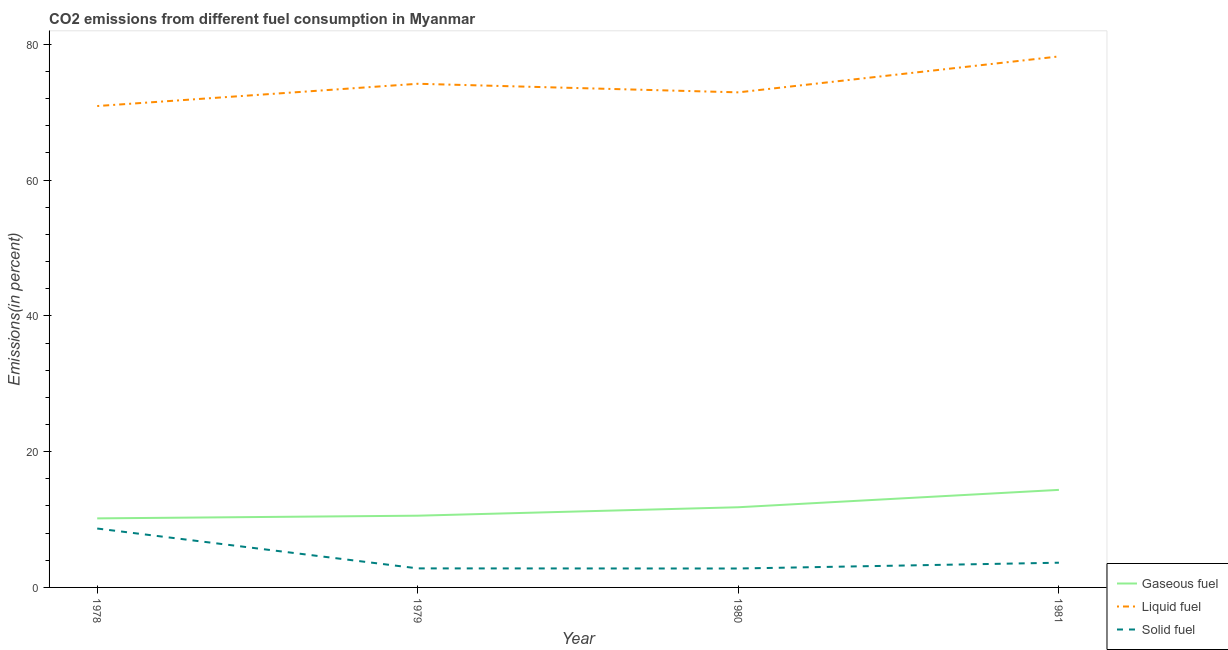How many different coloured lines are there?
Your answer should be compact. 3. Is the number of lines equal to the number of legend labels?
Ensure brevity in your answer.  Yes. What is the percentage of liquid fuel emission in 1978?
Your answer should be compact. 70.91. Across all years, what is the maximum percentage of gaseous fuel emission?
Ensure brevity in your answer.  14.37. Across all years, what is the minimum percentage of gaseous fuel emission?
Your answer should be compact. 10.17. In which year was the percentage of gaseous fuel emission maximum?
Provide a short and direct response. 1981. In which year was the percentage of gaseous fuel emission minimum?
Provide a short and direct response. 1978. What is the total percentage of solid fuel emission in the graph?
Your response must be concise. 17.91. What is the difference between the percentage of liquid fuel emission in 1979 and that in 1980?
Your response must be concise. 1.26. What is the difference between the percentage of gaseous fuel emission in 1980 and the percentage of liquid fuel emission in 1979?
Ensure brevity in your answer.  -62.38. What is the average percentage of gaseous fuel emission per year?
Give a very brief answer. 11.73. In the year 1980, what is the difference between the percentage of gaseous fuel emission and percentage of solid fuel emission?
Provide a short and direct response. 9.02. In how many years, is the percentage of liquid fuel emission greater than 16 %?
Your response must be concise. 4. What is the ratio of the percentage of liquid fuel emission in 1979 to that in 1980?
Provide a succinct answer. 1.02. Is the percentage of solid fuel emission in 1979 less than that in 1981?
Offer a terse response. Yes. Is the difference between the percentage of liquid fuel emission in 1978 and 1981 greater than the difference between the percentage of solid fuel emission in 1978 and 1981?
Offer a terse response. No. What is the difference between the highest and the second highest percentage of gaseous fuel emission?
Provide a short and direct response. 2.56. What is the difference between the highest and the lowest percentage of solid fuel emission?
Offer a very short reply. 5.89. In how many years, is the percentage of solid fuel emission greater than the average percentage of solid fuel emission taken over all years?
Provide a short and direct response. 1. Is it the case that in every year, the sum of the percentage of gaseous fuel emission and percentage of liquid fuel emission is greater than the percentage of solid fuel emission?
Your answer should be compact. Yes. Is the percentage of solid fuel emission strictly greater than the percentage of gaseous fuel emission over the years?
Your answer should be compact. No. How many years are there in the graph?
Offer a very short reply. 4. What is the difference between two consecutive major ticks on the Y-axis?
Make the answer very short. 20. Where does the legend appear in the graph?
Offer a very short reply. Bottom right. How many legend labels are there?
Provide a short and direct response. 3. How are the legend labels stacked?
Keep it short and to the point. Vertical. What is the title of the graph?
Your answer should be very brief. CO2 emissions from different fuel consumption in Myanmar. Does "Ages 15-20" appear as one of the legend labels in the graph?
Provide a short and direct response. No. What is the label or title of the X-axis?
Offer a very short reply. Year. What is the label or title of the Y-axis?
Give a very brief answer. Emissions(in percent). What is the Emissions(in percent) of Gaseous fuel in 1978?
Offer a terse response. 10.17. What is the Emissions(in percent) in Liquid fuel in 1978?
Offer a very short reply. 70.91. What is the Emissions(in percent) in Solid fuel in 1978?
Provide a short and direct response. 8.68. What is the Emissions(in percent) in Gaseous fuel in 1979?
Give a very brief answer. 10.57. What is the Emissions(in percent) of Liquid fuel in 1979?
Give a very brief answer. 74.19. What is the Emissions(in percent) in Solid fuel in 1979?
Ensure brevity in your answer.  2.8. What is the Emissions(in percent) in Gaseous fuel in 1980?
Keep it short and to the point. 11.81. What is the Emissions(in percent) in Liquid fuel in 1980?
Offer a terse response. 72.93. What is the Emissions(in percent) of Solid fuel in 1980?
Offer a terse response. 2.79. What is the Emissions(in percent) in Gaseous fuel in 1981?
Keep it short and to the point. 14.37. What is the Emissions(in percent) in Liquid fuel in 1981?
Provide a succinct answer. 78.22. What is the Emissions(in percent) in Solid fuel in 1981?
Your response must be concise. 3.64. Across all years, what is the maximum Emissions(in percent) in Gaseous fuel?
Provide a short and direct response. 14.37. Across all years, what is the maximum Emissions(in percent) in Liquid fuel?
Make the answer very short. 78.22. Across all years, what is the maximum Emissions(in percent) of Solid fuel?
Make the answer very short. 8.68. Across all years, what is the minimum Emissions(in percent) of Gaseous fuel?
Provide a succinct answer. 10.17. Across all years, what is the minimum Emissions(in percent) in Liquid fuel?
Make the answer very short. 70.91. Across all years, what is the minimum Emissions(in percent) in Solid fuel?
Provide a short and direct response. 2.79. What is the total Emissions(in percent) in Gaseous fuel in the graph?
Offer a terse response. 46.92. What is the total Emissions(in percent) in Liquid fuel in the graph?
Your answer should be very brief. 296.25. What is the total Emissions(in percent) in Solid fuel in the graph?
Offer a very short reply. 17.91. What is the difference between the Emissions(in percent) of Gaseous fuel in 1978 and that in 1979?
Your answer should be compact. -0.4. What is the difference between the Emissions(in percent) in Liquid fuel in 1978 and that in 1979?
Offer a very short reply. -3.28. What is the difference between the Emissions(in percent) in Solid fuel in 1978 and that in 1979?
Keep it short and to the point. 5.87. What is the difference between the Emissions(in percent) in Gaseous fuel in 1978 and that in 1980?
Provide a short and direct response. -1.64. What is the difference between the Emissions(in percent) in Liquid fuel in 1978 and that in 1980?
Your answer should be compact. -2.02. What is the difference between the Emissions(in percent) in Solid fuel in 1978 and that in 1980?
Give a very brief answer. 5.89. What is the difference between the Emissions(in percent) in Gaseous fuel in 1978 and that in 1981?
Your answer should be very brief. -4.2. What is the difference between the Emissions(in percent) of Liquid fuel in 1978 and that in 1981?
Your response must be concise. -7.31. What is the difference between the Emissions(in percent) of Solid fuel in 1978 and that in 1981?
Provide a succinct answer. 5.04. What is the difference between the Emissions(in percent) of Gaseous fuel in 1979 and that in 1980?
Your response must be concise. -1.24. What is the difference between the Emissions(in percent) of Liquid fuel in 1979 and that in 1980?
Ensure brevity in your answer.  1.26. What is the difference between the Emissions(in percent) of Solid fuel in 1979 and that in 1980?
Your answer should be compact. 0.02. What is the difference between the Emissions(in percent) in Gaseous fuel in 1979 and that in 1981?
Offer a very short reply. -3.8. What is the difference between the Emissions(in percent) of Liquid fuel in 1979 and that in 1981?
Make the answer very short. -4.03. What is the difference between the Emissions(in percent) in Solid fuel in 1979 and that in 1981?
Your response must be concise. -0.84. What is the difference between the Emissions(in percent) of Gaseous fuel in 1980 and that in 1981?
Provide a succinct answer. -2.56. What is the difference between the Emissions(in percent) in Liquid fuel in 1980 and that in 1981?
Your response must be concise. -5.29. What is the difference between the Emissions(in percent) in Solid fuel in 1980 and that in 1981?
Provide a short and direct response. -0.85. What is the difference between the Emissions(in percent) in Gaseous fuel in 1978 and the Emissions(in percent) in Liquid fuel in 1979?
Your response must be concise. -64.02. What is the difference between the Emissions(in percent) of Gaseous fuel in 1978 and the Emissions(in percent) of Solid fuel in 1979?
Ensure brevity in your answer.  7.37. What is the difference between the Emissions(in percent) of Liquid fuel in 1978 and the Emissions(in percent) of Solid fuel in 1979?
Make the answer very short. 68.11. What is the difference between the Emissions(in percent) of Gaseous fuel in 1978 and the Emissions(in percent) of Liquid fuel in 1980?
Give a very brief answer. -62.76. What is the difference between the Emissions(in percent) in Gaseous fuel in 1978 and the Emissions(in percent) in Solid fuel in 1980?
Provide a succinct answer. 7.38. What is the difference between the Emissions(in percent) in Liquid fuel in 1978 and the Emissions(in percent) in Solid fuel in 1980?
Make the answer very short. 68.12. What is the difference between the Emissions(in percent) in Gaseous fuel in 1978 and the Emissions(in percent) in Liquid fuel in 1981?
Your response must be concise. -68.05. What is the difference between the Emissions(in percent) of Gaseous fuel in 1978 and the Emissions(in percent) of Solid fuel in 1981?
Your response must be concise. 6.53. What is the difference between the Emissions(in percent) of Liquid fuel in 1978 and the Emissions(in percent) of Solid fuel in 1981?
Make the answer very short. 67.27. What is the difference between the Emissions(in percent) of Gaseous fuel in 1979 and the Emissions(in percent) of Liquid fuel in 1980?
Offer a terse response. -62.36. What is the difference between the Emissions(in percent) in Gaseous fuel in 1979 and the Emissions(in percent) in Solid fuel in 1980?
Ensure brevity in your answer.  7.78. What is the difference between the Emissions(in percent) in Liquid fuel in 1979 and the Emissions(in percent) in Solid fuel in 1980?
Offer a very short reply. 71.4. What is the difference between the Emissions(in percent) of Gaseous fuel in 1979 and the Emissions(in percent) of Liquid fuel in 1981?
Your response must be concise. -67.65. What is the difference between the Emissions(in percent) in Gaseous fuel in 1979 and the Emissions(in percent) in Solid fuel in 1981?
Your answer should be compact. 6.93. What is the difference between the Emissions(in percent) of Liquid fuel in 1979 and the Emissions(in percent) of Solid fuel in 1981?
Keep it short and to the point. 70.55. What is the difference between the Emissions(in percent) of Gaseous fuel in 1980 and the Emissions(in percent) of Liquid fuel in 1981?
Give a very brief answer. -66.41. What is the difference between the Emissions(in percent) in Gaseous fuel in 1980 and the Emissions(in percent) in Solid fuel in 1981?
Keep it short and to the point. 8.17. What is the difference between the Emissions(in percent) in Liquid fuel in 1980 and the Emissions(in percent) in Solid fuel in 1981?
Keep it short and to the point. 69.29. What is the average Emissions(in percent) of Gaseous fuel per year?
Give a very brief answer. 11.73. What is the average Emissions(in percent) in Liquid fuel per year?
Provide a succinct answer. 74.06. What is the average Emissions(in percent) in Solid fuel per year?
Offer a very short reply. 4.48. In the year 1978, what is the difference between the Emissions(in percent) in Gaseous fuel and Emissions(in percent) in Liquid fuel?
Provide a short and direct response. -60.74. In the year 1978, what is the difference between the Emissions(in percent) of Gaseous fuel and Emissions(in percent) of Solid fuel?
Give a very brief answer. 1.49. In the year 1978, what is the difference between the Emissions(in percent) of Liquid fuel and Emissions(in percent) of Solid fuel?
Provide a succinct answer. 62.23. In the year 1979, what is the difference between the Emissions(in percent) in Gaseous fuel and Emissions(in percent) in Liquid fuel?
Offer a very short reply. -63.62. In the year 1979, what is the difference between the Emissions(in percent) of Gaseous fuel and Emissions(in percent) of Solid fuel?
Ensure brevity in your answer.  7.76. In the year 1979, what is the difference between the Emissions(in percent) of Liquid fuel and Emissions(in percent) of Solid fuel?
Ensure brevity in your answer.  71.39. In the year 1980, what is the difference between the Emissions(in percent) in Gaseous fuel and Emissions(in percent) in Liquid fuel?
Provide a succinct answer. -61.11. In the year 1980, what is the difference between the Emissions(in percent) in Gaseous fuel and Emissions(in percent) in Solid fuel?
Make the answer very short. 9.02. In the year 1980, what is the difference between the Emissions(in percent) of Liquid fuel and Emissions(in percent) of Solid fuel?
Offer a very short reply. 70.14. In the year 1981, what is the difference between the Emissions(in percent) of Gaseous fuel and Emissions(in percent) of Liquid fuel?
Keep it short and to the point. -63.85. In the year 1981, what is the difference between the Emissions(in percent) of Gaseous fuel and Emissions(in percent) of Solid fuel?
Provide a succinct answer. 10.73. In the year 1981, what is the difference between the Emissions(in percent) of Liquid fuel and Emissions(in percent) of Solid fuel?
Provide a succinct answer. 74.58. What is the ratio of the Emissions(in percent) in Gaseous fuel in 1978 to that in 1979?
Make the answer very short. 0.96. What is the ratio of the Emissions(in percent) of Liquid fuel in 1978 to that in 1979?
Make the answer very short. 0.96. What is the ratio of the Emissions(in percent) of Solid fuel in 1978 to that in 1979?
Provide a short and direct response. 3.09. What is the ratio of the Emissions(in percent) in Gaseous fuel in 1978 to that in 1980?
Offer a terse response. 0.86. What is the ratio of the Emissions(in percent) in Liquid fuel in 1978 to that in 1980?
Offer a very short reply. 0.97. What is the ratio of the Emissions(in percent) of Solid fuel in 1978 to that in 1980?
Your response must be concise. 3.11. What is the ratio of the Emissions(in percent) of Gaseous fuel in 1978 to that in 1981?
Offer a very short reply. 0.71. What is the ratio of the Emissions(in percent) of Liquid fuel in 1978 to that in 1981?
Keep it short and to the point. 0.91. What is the ratio of the Emissions(in percent) of Solid fuel in 1978 to that in 1981?
Ensure brevity in your answer.  2.38. What is the ratio of the Emissions(in percent) of Gaseous fuel in 1979 to that in 1980?
Ensure brevity in your answer.  0.89. What is the ratio of the Emissions(in percent) in Liquid fuel in 1979 to that in 1980?
Your response must be concise. 1.02. What is the ratio of the Emissions(in percent) of Gaseous fuel in 1979 to that in 1981?
Your response must be concise. 0.74. What is the ratio of the Emissions(in percent) in Liquid fuel in 1979 to that in 1981?
Offer a very short reply. 0.95. What is the ratio of the Emissions(in percent) of Solid fuel in 1979 to that in 1981?
Provide a succinct answer. 0.77. What is the ratio of the Emissions(in percent) in Gaseous fuel in 1980 to that in 1981?
Keep it short and to the point. 0.82. What is the ratio of the Emissions(in percent) in Liquid fuel in 1980 to that in 1981?
Provide a short and direct response. 0.93. What is the ratio of the Emissions(in percent) of Solid fuel in 1980 to that in 1981?
Offer a terse response. 0.77. What is the difference between the highest and the second highest Emissions(in percent) in Gaseous fuel?
Offer a terse response. 2.56. What is the difference between the highest and the second highest Emissions(in percent) in Liquid fuel?
Provide a short and direct response. 4.03. What is the difference between the highest and the second highest Emissions(in percent) in Solid fuel?
Offer a terse response. 5.04. What is the difference between the highest and the lowest Emissions(in percent) of Gaseous fuel?
Provide a short and direct response. 4.2. What is the difference between the highest and the lowest Emissions(in percent) in Liquid fuel?
Provide a short and direct response. 7.31. What is the difference between the highest and the lowest Emissions(in percent) of Solid fuel?
Give a very brief answer. 5.89. 